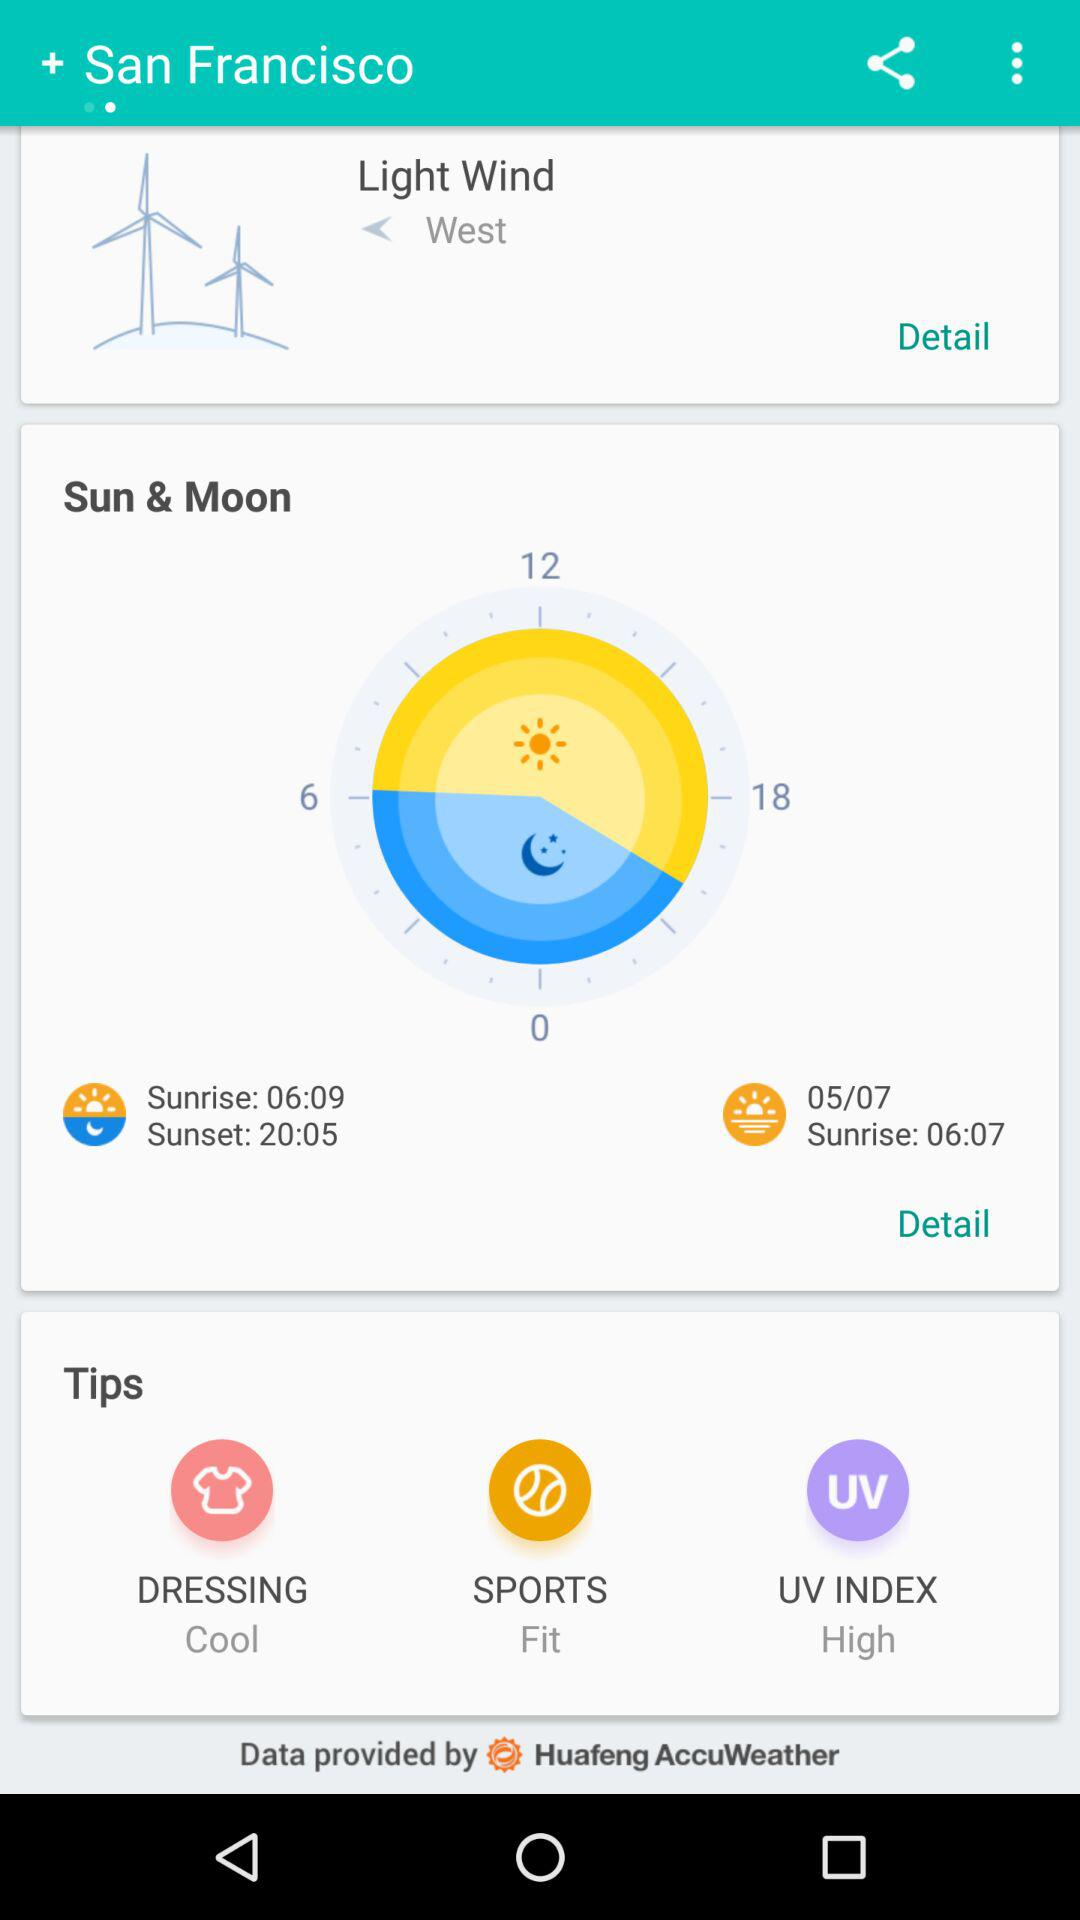What's the direction of wind? The direction of the wind is west. 